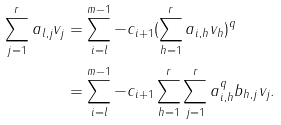<formula> <loc_0><loc_0><loc_500><loc_500>\sum _ { j = 1 } ^ { r } a _ { l , j } v _ { j } & = \sum _ { i = l } ^ { m - 1 } - c _ { i + 1 } ( \sum _ { h = 1 } ^ { r } a _ { i , h } v _ { h } ) ^ { q } \\ & = \sum _ { i = l } ^ { m - 1 } - c _ { i + 1 } \sum _ { h = 1 } ^ { r } \sum _ { j = 1 } ^ { r } a _ { i , h } ^ { q } b _ { h , j } v _ { j } .</formula> 